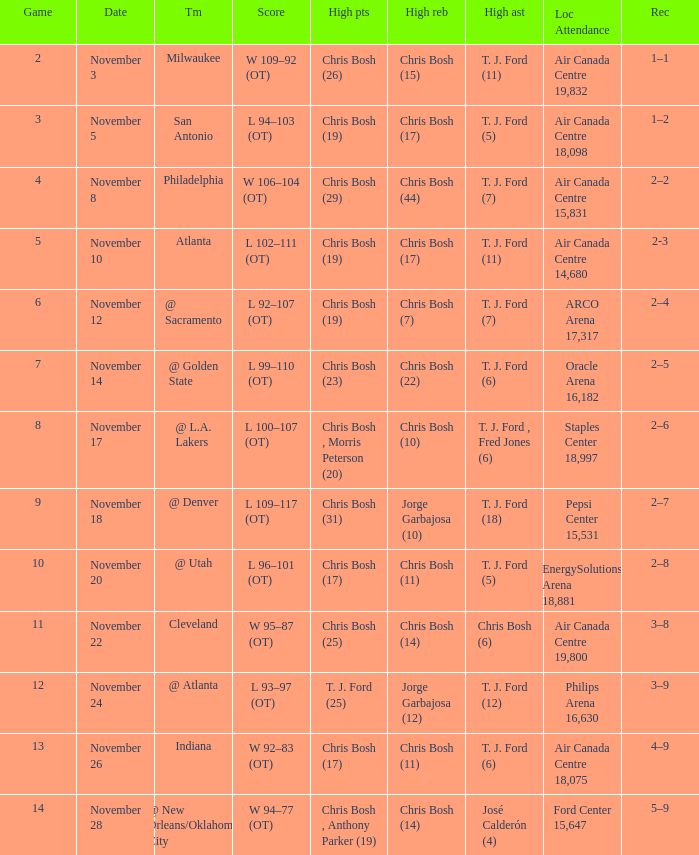Who had high assists when they played against San Antonio? T. J. Ford (5). 